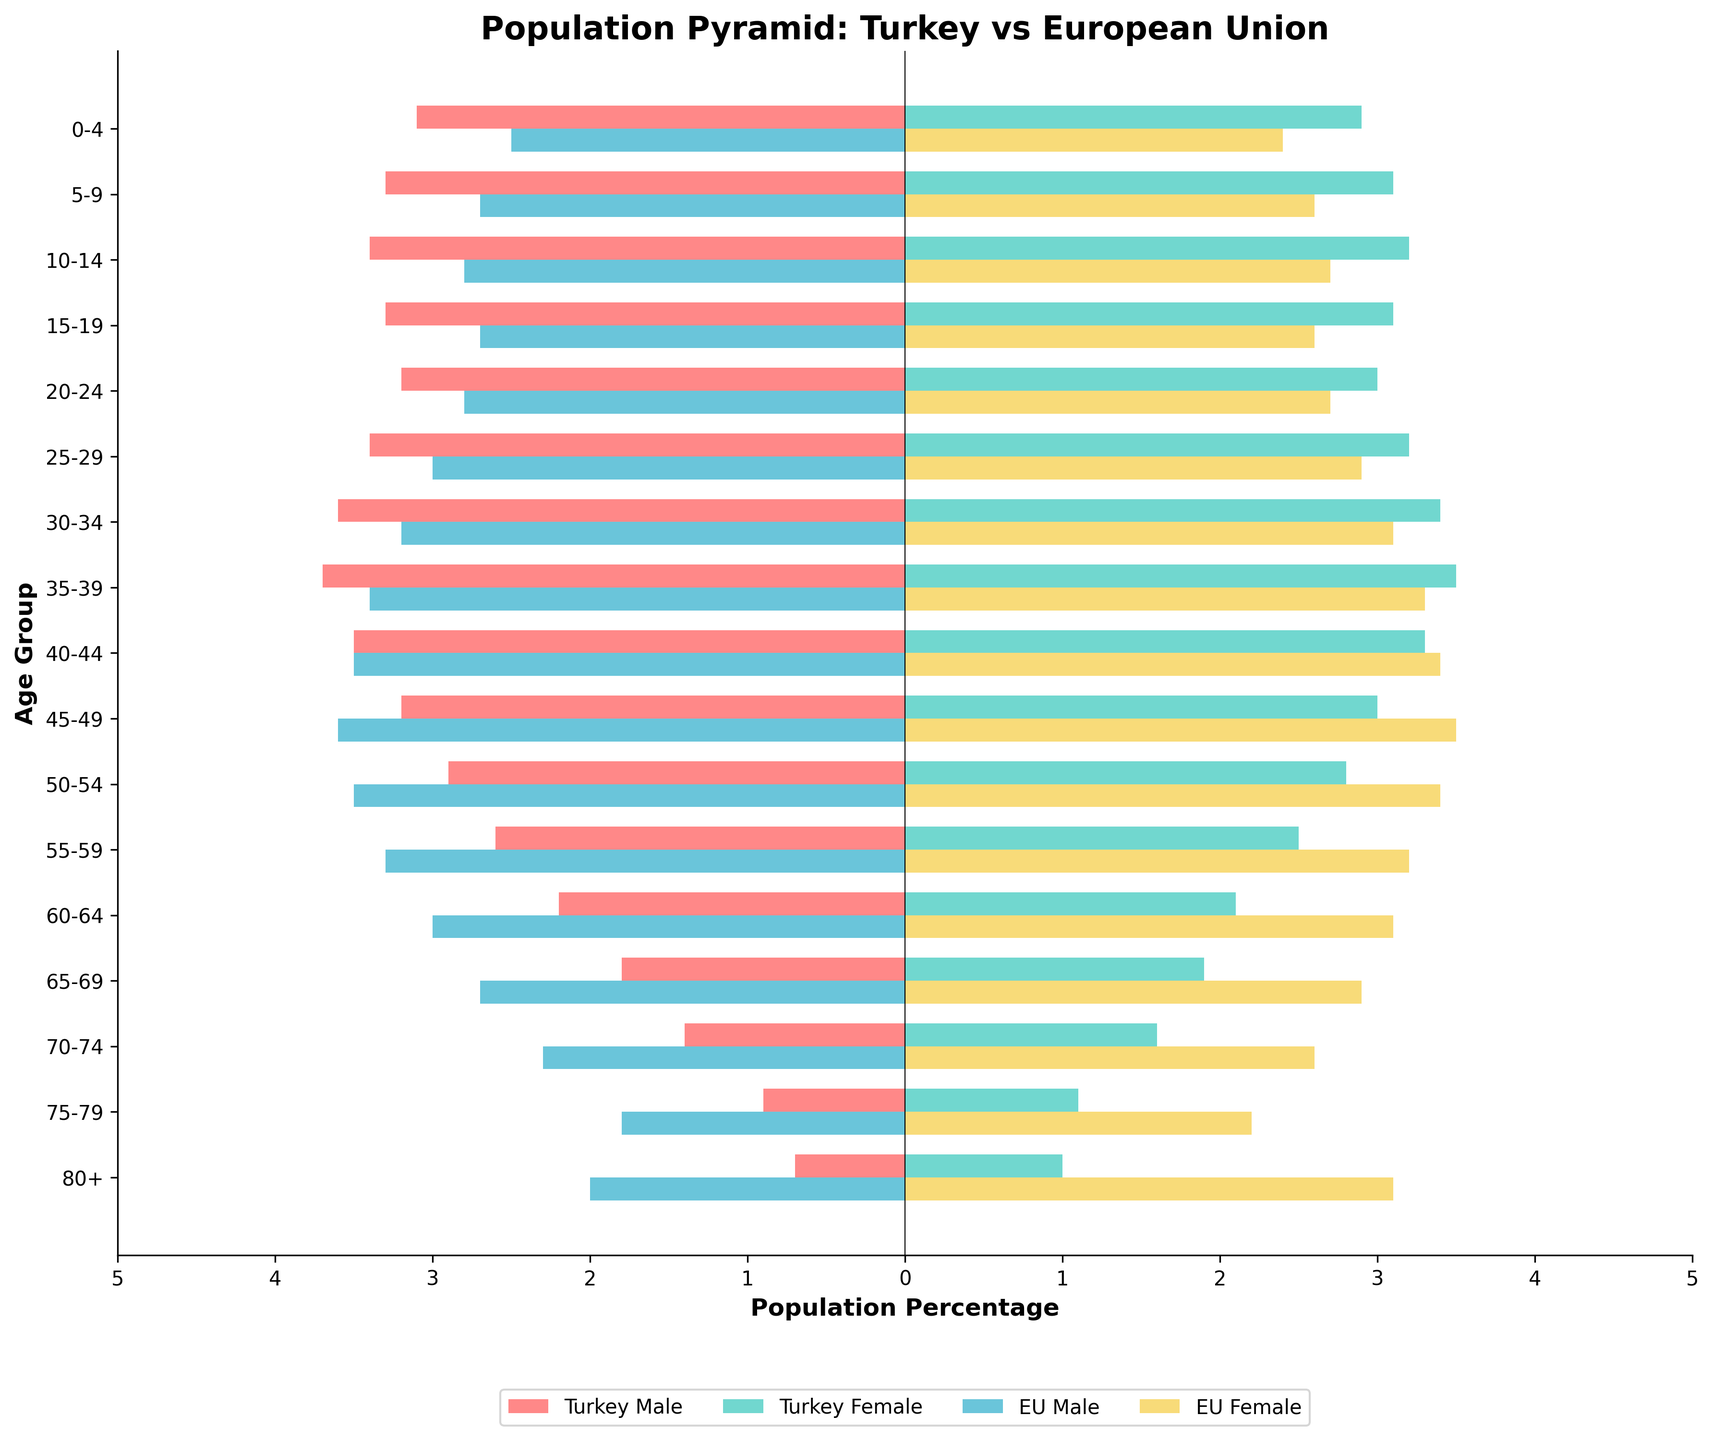What is the title of the figure? The title is located at the top of the plot. It summarizes the comparison being made in the figure, which is between the age structures of Turkey and the European Union.
Answer: Population Pyramid: Turkey vs European Union How do the population percentages of Turkey and the EU compare in the 0-4 age group? The 0-4 age group shows Turkey Male at -3.1%, Turkey Female at 2.9%, EU Male at -2.5%, and EU Female at 2.4%. By comparing these, it's clear that Turkey has a higher percentage of both males and females in this age group compared to the EU.
Answer: Turkey has higher percentages in the 0-4 age group Which age group has the highest percentage difference between Turkey Male and EU Male? The highest percentage difference can be found by comparing the percentages for each age group between Turkey Male and EU Male. The age group 0-4 shows -3.1% for Turkey Male and -2.5% for EU Male giving a difference of 0.6%. This is the highest difference when compared to other age groups.
Answer: 0-4 What's the percentage of EU females aged 80+? The percentage for EU females aged 80+ is shown in the bar corresponding to that age group. The exact value is 3.1%.
Answer: 3.1% Which gender has a larger elderly population in the EU according to the 80+ age group? The percentage for EU females aged 80+ is 3.1%, whereas for EU males it is 2.0%. Comparing these values indicates that there is a larger percentage of elderly females in the EU.
Answer: Females In the age group 15-19, which region has a higher percentage of females, Turkey or the EU? For the age group 15-19, Turkey has 3.1% females and the EU has 2.6% females. Comparing these values, Turkey has a higher percentage of females.
Answer: Turkey Which age group shows almost equal percentages of males and females in Turkey? The age group with almost equal percentages for males and females can be found by comparing the two values for each age group. In the 50-54 age group, males are 2.9%, and females are 2.8%, which are close to being equal.
Answer: 50-54 Compare the population percentages of Turkey and EU females in the 30-34 age group. For the age group 30-34, Turkey Female is at 3.4%, and EU Female is at 3.1%. Comparing these, Turkey has a slightly higher percentage of females in this age group.
Answer: Turkey has a higher percentage in this age group What is the trend in the percentage of Turkey females as age increases? As age increases, the percentage of Turkey females generally decreases. This trend is visible as we move from the younger age groups (e.g., 3.2% for 25-29) to the older age groups (e.g., 1.0% for 80+).
Answer: General decreasing trend What is the total percentage of the male population in Turkey for the age groups from 0-4 to 14-19? Summing the percentages for the male population in Turkey in the age groups from 0-4 to 14-19: 3.1% + 3.3% + 3.4% + 3.3% = 13.1%.
Answer: 13.1% 